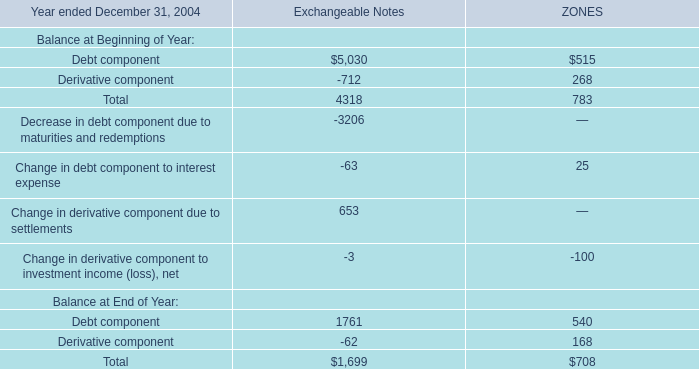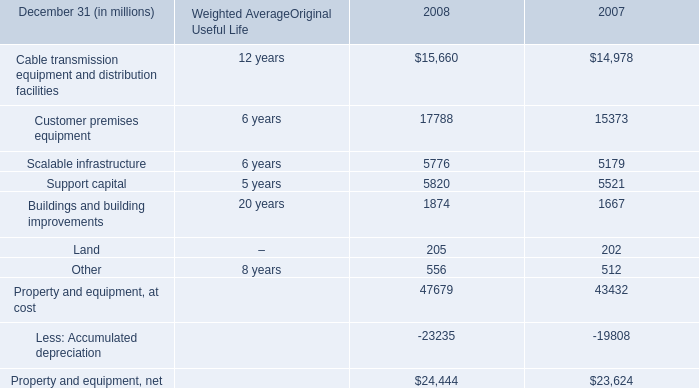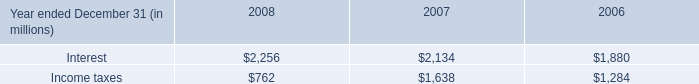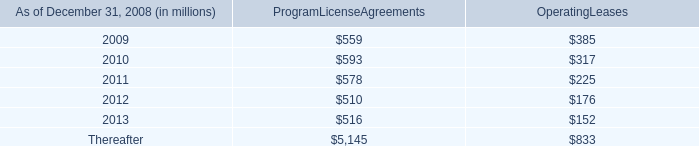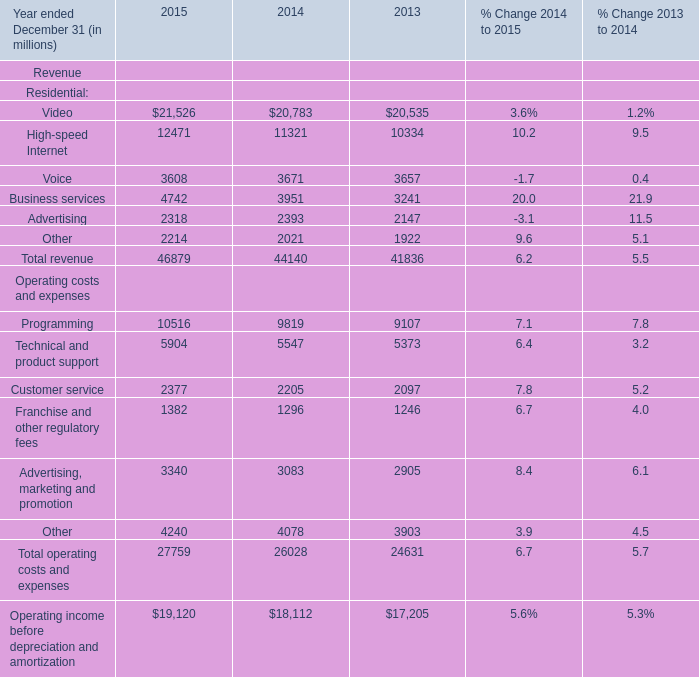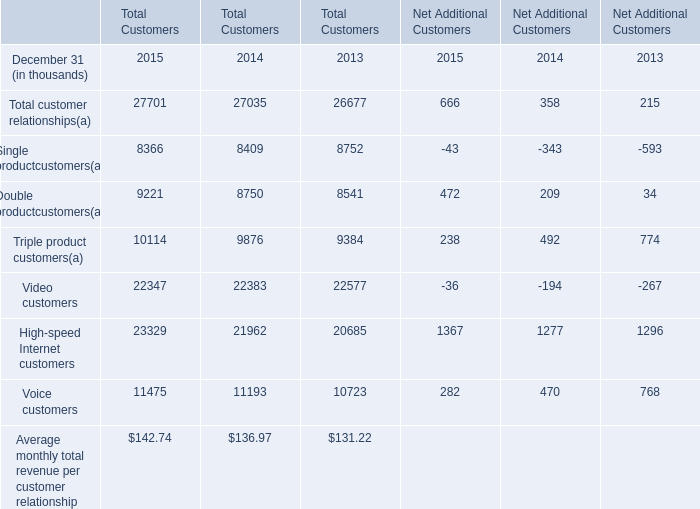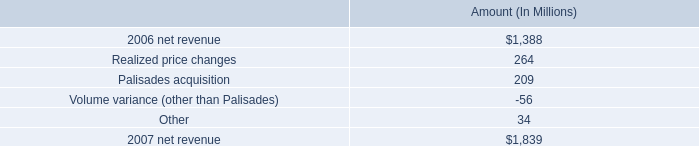What was the average of the High-speed Internet and Programming in the years where Business services is positive? (in million) 
Computations: ((12471 + 10516) / 2)
Answer: 11493.5. 